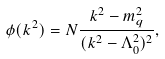Convert formula to latex. <formula><loc_0><loc_0><loc_500><loc_500>\phi ( k ^ { 2 } ) = N \frac { k ^ { 2 } - m _ { q } ^ { 2 } } { ( k ^ { 2 } - \Lambda _ { 0 } ^ { 2 } ) ^ { 2 } } ,</formula> 